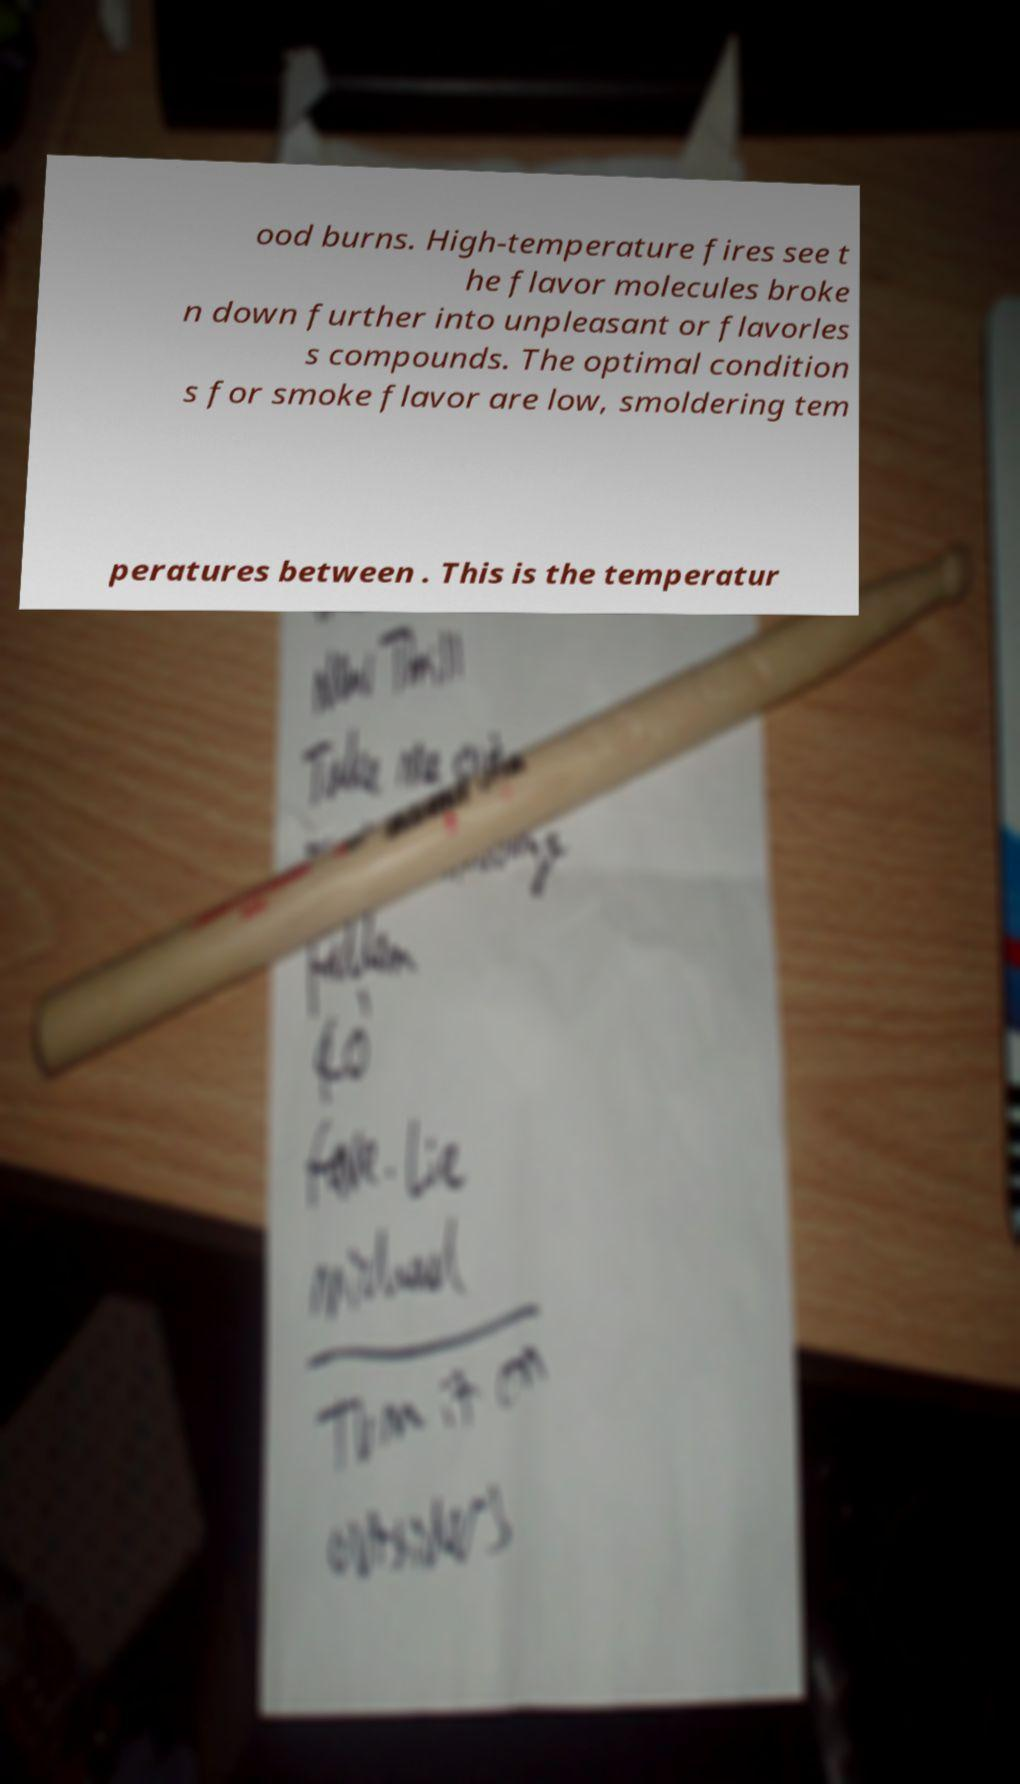Can you read and provide the text displayed in the image?This photo seems to have some interesting text. Can you extract and type it out for me? ood burns. High-temperature fires see t he flavor molecules broke n down further into unpleasant or flavorles s compounds. The optimal condition s for smoke flavor are low, smoldering tem peratures between . This is the temperatur 